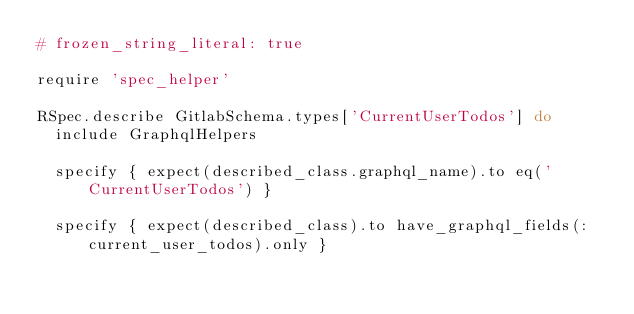<code> <loc_0><loc_0><loc_500><loc_500><_Ruby_># frozen_string_literal: true

require 'spec_helper'

RSpec.describe GitlabSchema.types['CurrentUserTodos'] do
  include GraphqlHelpers

  specify { expect(described_class.graphql_name).to eq('CurrentUserTodos') }

  specify { expect(described_class).to have_graphql_fields(:current_user_todos).only }
</code> 